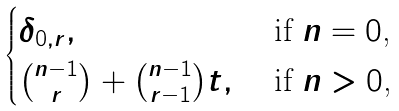Convert formula to latex. <formula><loc_0><loc_0><loc_500><loc_500>\begin{cases} \delta _ { 0 , r } , & \text { if $n=0$,} \\ \binom { n - 1 } { r } + \binom { n - 1 } { r - 1 } t , & \text { if $n>0$,} \end{cases}</formula> 